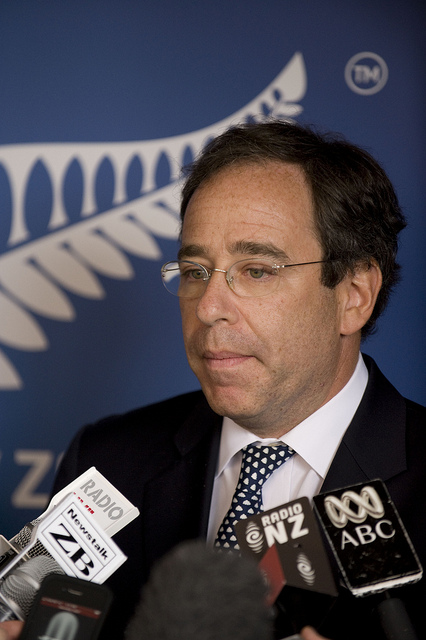Identify the text displayed in this image. ABC NZ ZB RADIO ZB RADIO 